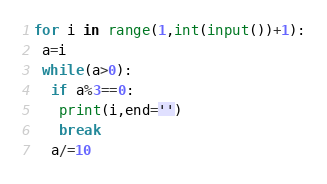Convert code to text. <code><loc_0><loc_0><loc_500><loc_500><_Python_>for i in range(1,int(input())+1):
 a=i
 while(a>0):
  if a%3==0:
   print(i,end='')
   break
  a/=10</code> 